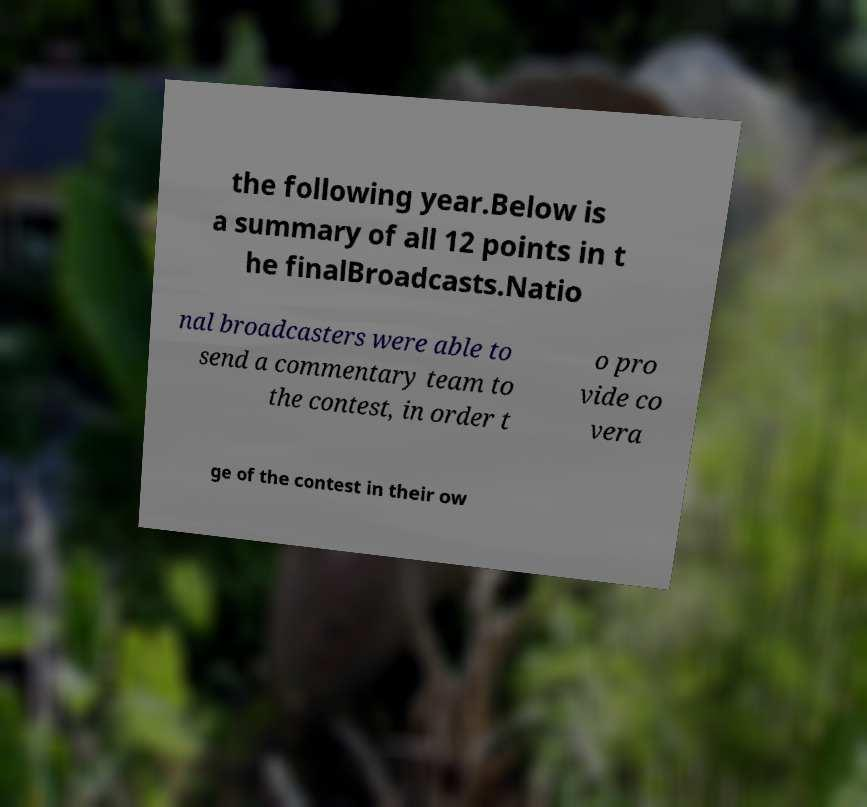Can you accurately transcribe the text from the provided image for me? the following year.Below is a summary of all 12 points in t he finalBroadcasts.Natio nal broadcasters were able to send a commentary team to the contest, in order t o pro vide co vera ge of the contest in their ow 